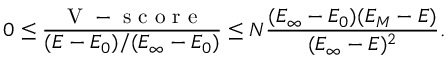Convert formula to latex. <formula><loc_0><loc_0><loc_500><loc_500>0 \leq \frac { V - s c o r e } { ( E - E _ { 0 } ) / ( E _ { \infty } - E _ { 0 } ) } \leq N \frac { ( E _ { \infty } - E _ { 0 } ) ( E _ { M } - E ) } { ( E _ { \infty } - E ) ^ { 2 } } .</formula> 